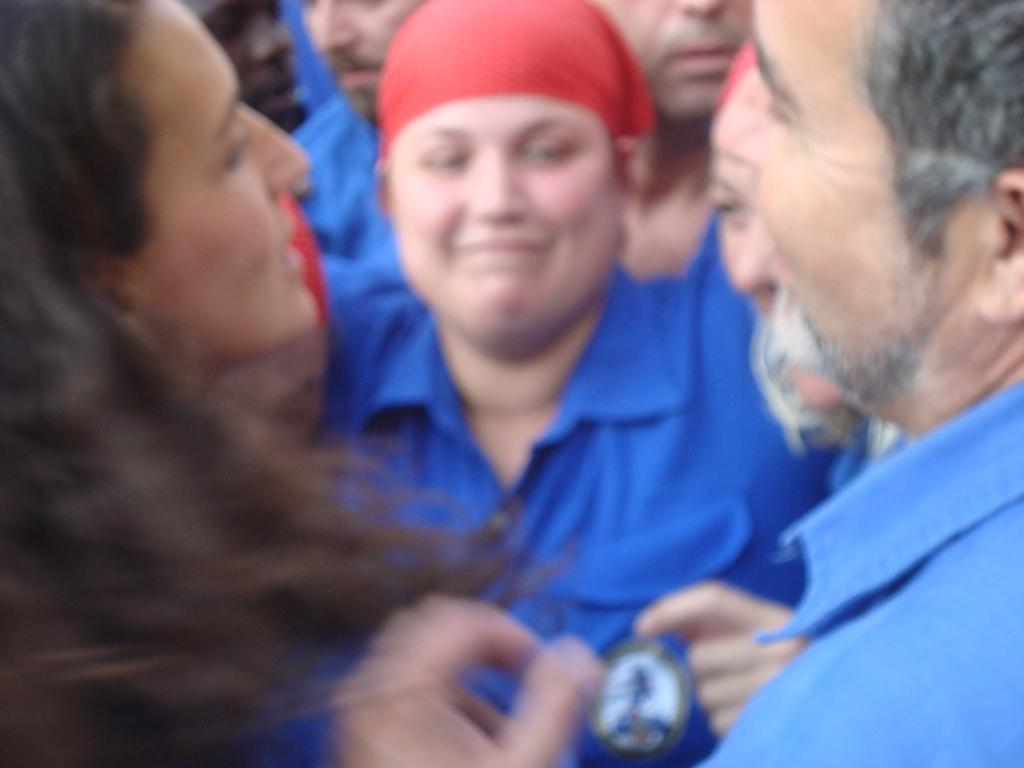How many individuals are present in the image? There are many people in the image. Can you describe any specific clothing or accessories worn by someone in the image? Yes, there is a person wearing a cap in the image. What government policy is being discussed by the people in the image? There is no indication in the image that the people are discussing any government policies. 